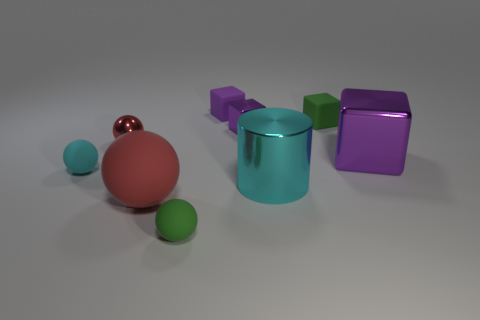Are there the same number of shiny things on the left side of the cyan metal thing and small metal blocks behind the tiny metal cube?
Your answer should be compact. No. How many other objects are there of the same material as the big purple block?
Ensure brevity in your answer.  3. What number of metal things are purple things or tiny yellow things?
Your response must be concise. 2. There is a purple shiny thing that is in front of the tiny metallic ball; is it the same shape as the big red rubber thing?
Provide a short and direct response. No. Is the number of tiny purple rubber objects to the right of the tiny green matte cube greater than the number of balls?
Your answer should be compact. No. How many things are behind the large purple object and in front of the big purple cube?
Your answer should be compact. 0. There is a matte cube that is to the left of the cyan thing in front of the cyan matte object; what is its color?
Ensure brevity in your answer.  Purple. What number of tiny metal objects are the same color as the large metallic cylinder?
Offer a very short reply. 0. Do the metal cylinder and the tiny object that is in front of the large cylinder have the same color?
Provide a short and direct response. No. Are there fewer small cylinders than small green things?
Offer a very short reply. Yes. 